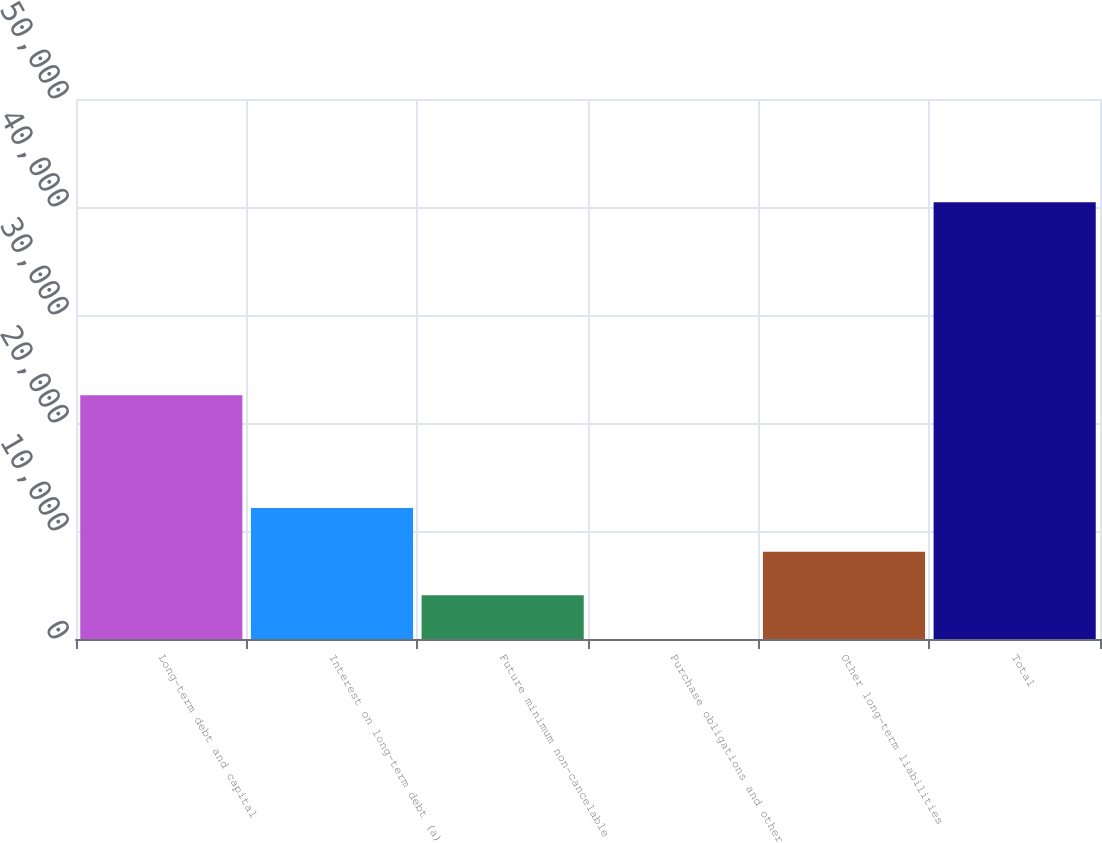Convert chart to OTSL. <chart><loc_0><loc_0><loc_500><loc_500><bar_chart><fcel>Long-term debt and capital<fcel>Interest on long-term debt (a)<fcel>Future minimum non-cancelable<fcel>Purchase obligations and other<fcel>Other long-term liabilities<fcel>Total<nl><fcel>22570<fcel>12132.5<fcel>4045.5<fcel>2<fcel>8089<fcel>40437<nl></chart> 